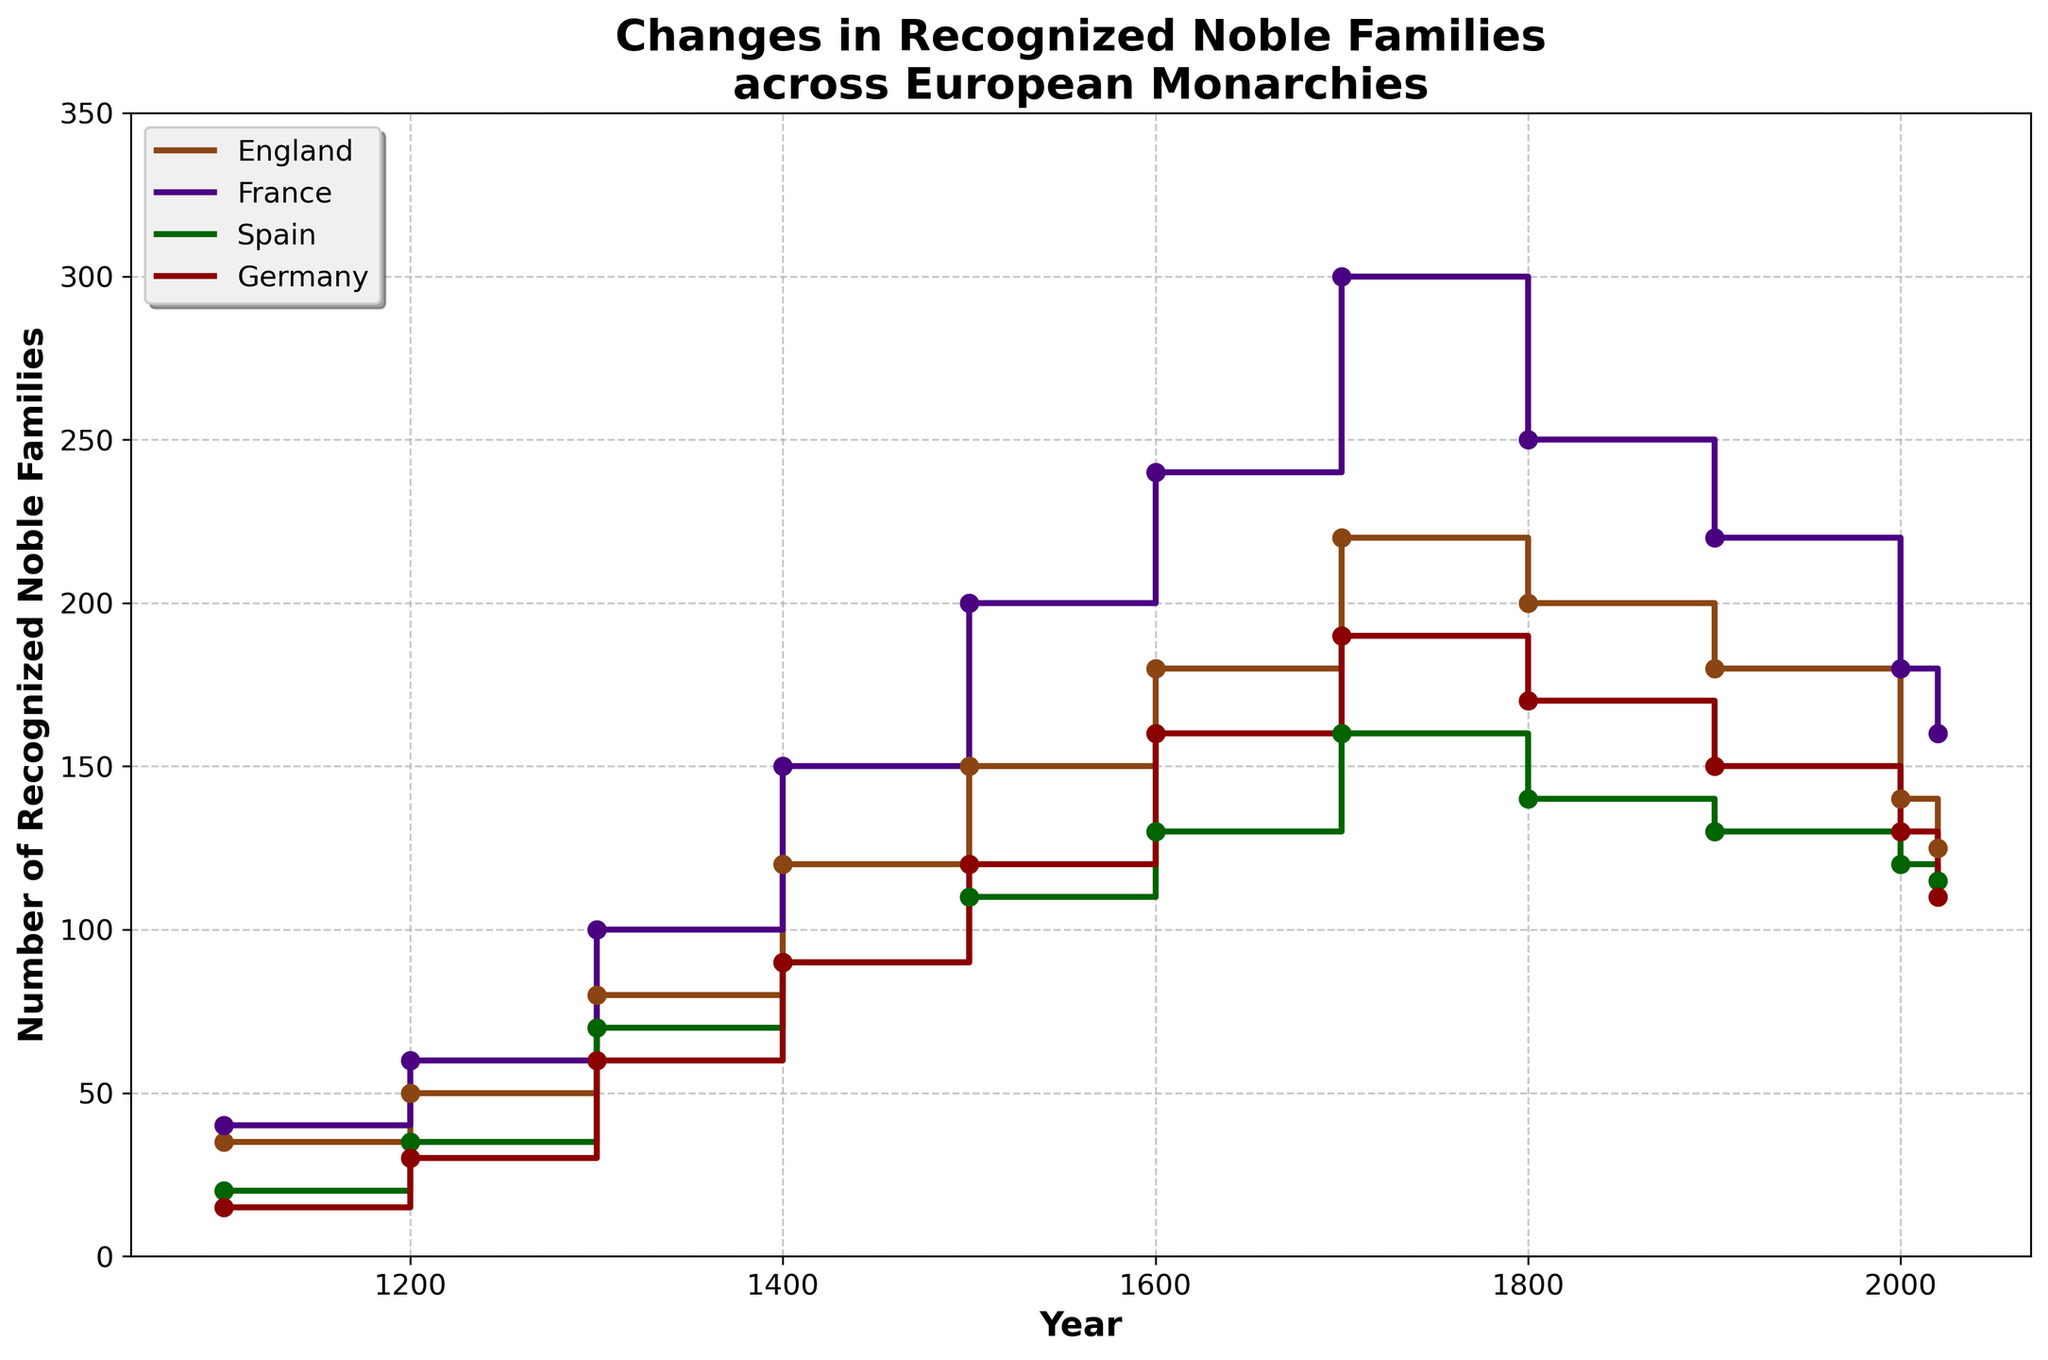What is the title of the figure? The title is located at the top of the figure. It reads "Changes in Recognized Noble Families across European Monarchies".
Answer: Changes in Recognized Noble Families across European Monarchies Which country had the highest number of recognized noble families around the year 1400? By observing the y-values at the year 1400 for each country's line, we see that France reaches 150 noble families.
Answer: France How many recognized noble families were there in Spain in the year 2000? Looking at the y-value where Spain's line corresponds to the year 2000 on the x-axis, we see it reaches 120.
Answer: 120 What is the total number of recognized noble families in England between 1500 and 1700 inclusive? For England, sum the counts at the years 1500, 1600, and 1700: 150 + 180 + 220 = 550.
Answer: 550 Which country experienced the largest decrease in the number of recognized noble families from their peak to 2020? By comparing the highest value and 2020 value for each country: England (220 to 125), France (300 to 160), Spain (160 to 115), Germany (190 to 110). The largest decrease is for France: 300 - 160 = 140.
Answer: France Between the years 1100 and 1300, which country showed the highest relative increase in the number of recognized noble families? Calculate the ratio of increase for each country. England: (80-35)/35 = 1.29; France: (100-40)/40 = 1.5; Spain: (70-20)/20 = 2.5; Germany: (60-15)/15 = 3. Germany has the highest increase.
Answer: Germany During which century did England experience the highest increase in the number of noble families? Review each century for England. The 1400s show an increase from 80 to 120, a difference of 40 families, which is the highest.
Answer: 1400s How does the number of recognized noble families in France in 1700 compare with that in Germany in the same year? By comparing the y-values at the year 1700, France is at 300, while Germany is at 190. France's number is higher.
Answer: France Which country’s number of recognized noble families remained fairly stable between 1900 and 2020? By examining the slopes and values for 1900 and 2020, Spain's numbers remained closest: 130 in 1900 and 115 in 2020.
Answer: Spain In which period did Germany see its number of recognized noble families decrease from a peak? Identify the highest point for Germany (1700, 190 families) and then check decrease after this year. The decrease occurred after 1700.
Answer: After 1700 